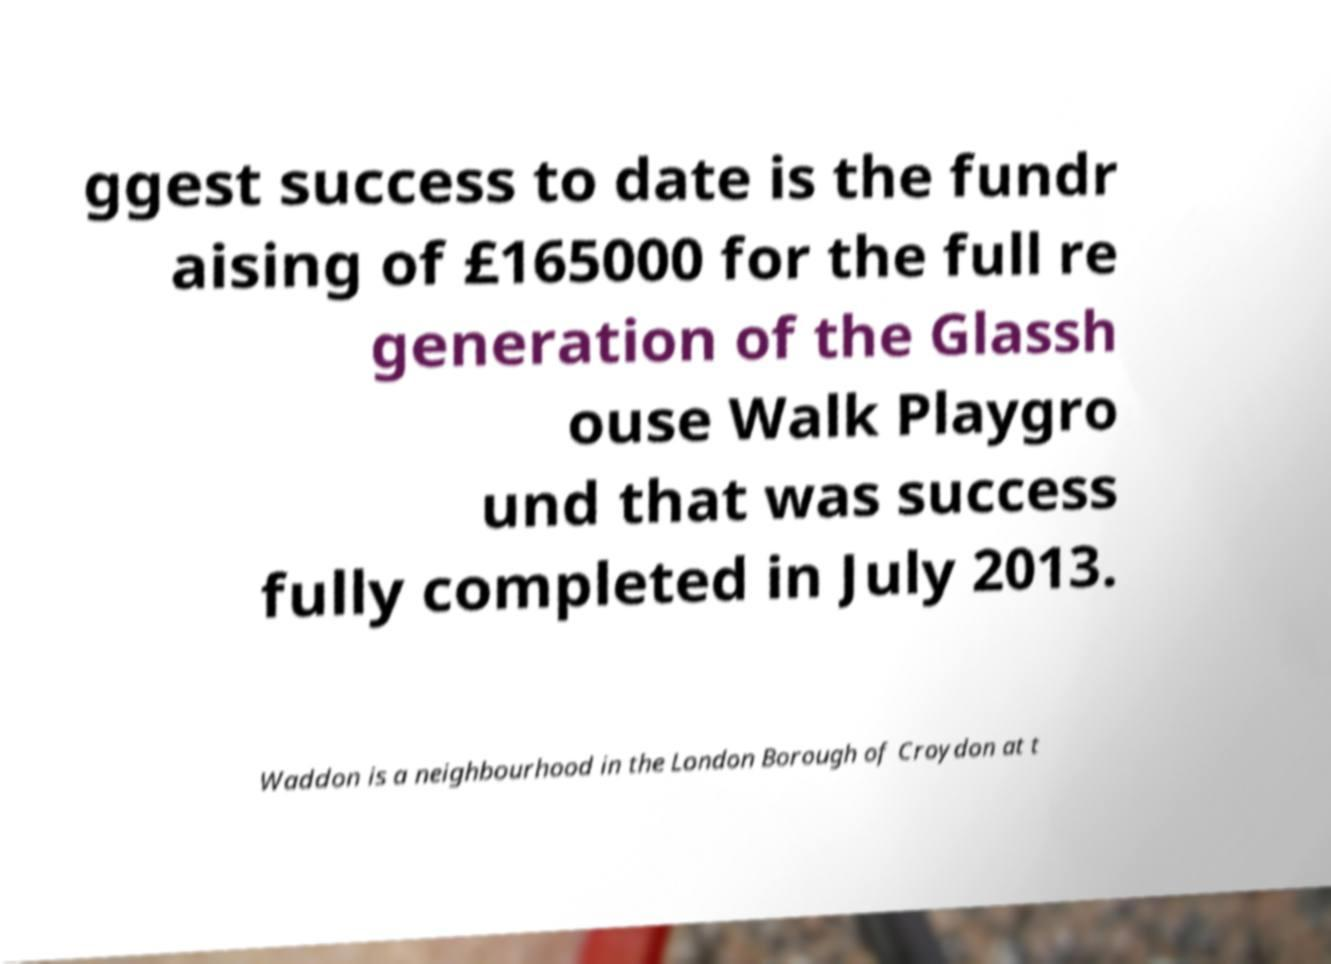I need the written content from this picture converted into text. Can you do that? ggest success to date is the fundr aising of £165000 for the full re generation of the Glassh ouse Walk Playgro und that was success fully completed in July 2013. Waddon is a neighbourhood in the London Borough of Croydon at t 